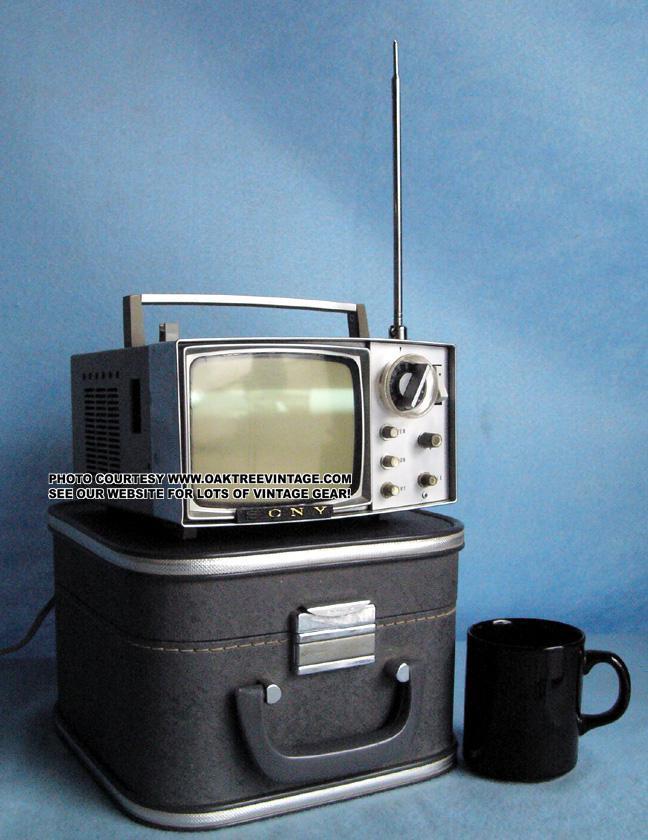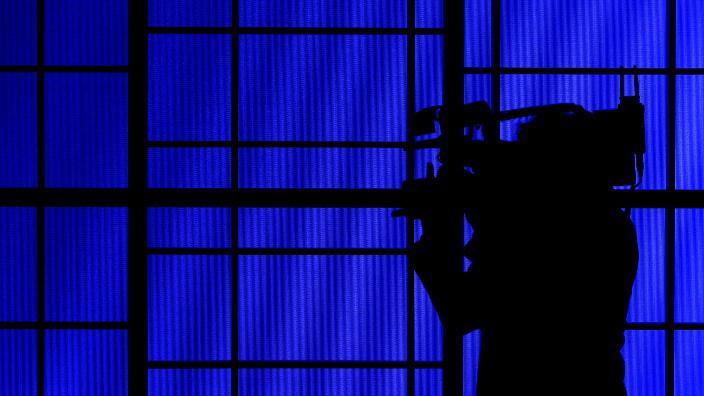The first image is the image on the left, the second image is the image on the right. For the images shown, is this caption "Chairs are available for people to view the screens in at least one of the images." true? Answer yes or no. No. The first image is the image on the left, the second image is the image on the right. Considering the images on both sides, is "One image depicts one or more televisions in a sports bar." valid? Answer yes or no. No. 